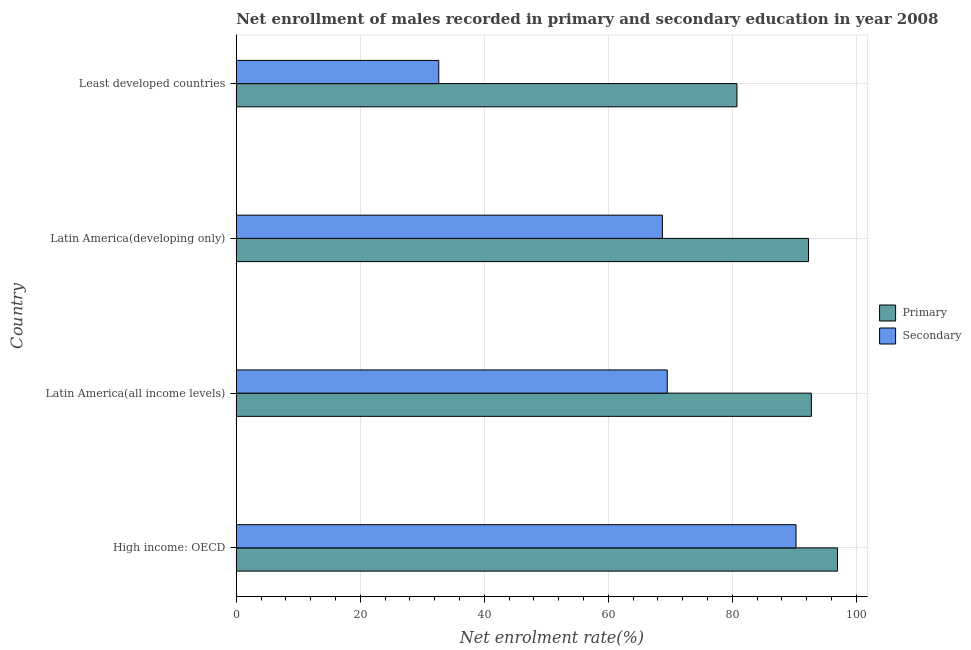Are the number of bars per tick equal to the number of legend labels?
Your answer should be compact. Yes. Are the number of bars on each tick of the Y-axis equal?
Offer a very short reply. Yes. How many bars are there on the 1st tick from the top?
Offer a terse response. 2. What is the label of the 1st group of bars from the top?
Provide a succinct answer. Least developed countries. In how many cases, is the number of bars for a given country not equal to the number of legend labels?
Make the answer very short. 0. What is the enrollment rate in primary education in Latin America(developing only)?
Offer a terse response. 92.29. Across all countries, what is the maximum enrollment rate in secondary education?
Provide a short and direct response. 90.28. Across all countries, what is the minimum enrollment rate in secondary education?
Offer a very short reply. 32.66. In which country was the enrollment rate in secondary education maximum?
Ensure brevity in your answer.  High income: OECD. In which country was the enrollment rate in secondary education minimum?
Provide a short and direct response. Least developed countries. What is the total enrollment rate in primary education in the graph?
Your answer should be compact. 362.76. What is the difference between the enrollment rate in primary education in Latin America(developing only) and that in Least developed countries?
Make the answer very short. 11.53. What is the difference between the enrollment rate in secondary education in High income: OECD and the enrollment rate in primary education in Latin America(developing only)?
Provide a succinct answer. -2.01. What is the average enrollment rate in secondary education per country?
Offer a terse response. 65.29. What is the difference between the enrollment rate in secondary education and enrollment rate in primary education in Latin America(all income levels)?
Provide a succinct answer. -23.24. In how many countries, is the enrollment rate in secondary education greater than 32 %?
Provide a short and direct response. 4. What is the ratio of the enrollment rate in primary education in Latin America(all income levels) to that in Least developed countries?
Give a very brief answer. 1.15. What is the difference between the highest and the second highest enrollment rate in secondary education?
Offer a terse response. 20.77. What is the difference between the highest and the lowest enrollment rate in secondary education?
Your answer should be very brief. 57.61. Is the sum of the enrollment rate in secondary education in High income: OECD and Latin America(all income levels) greater than the maximum enrollment rate in primary education across all countries?
Provide a succinct answer. Yes. What does the 2nd bar from the top in Least developed countries represents?
Give a very brief answer. Primary. What does the 2nd bar from the bottom in Latin America(developing only) represents?
Ensure brevity in your answer.  Secondary. How many bars are there?
Keep it short and to the point. 8. Does the graph contain any zero values?
Provide a short and direct response. No. Does the graph contain grids?
Offer a terse response. Yes. Where does the legend appear in the graph?
Your answer should be very brief. Center right. How many legend labels are there?
Ensure brevity in your answer.  2. How are the legend labels stacked?
Offer a terse response. Vertical. What is the title of the graph?
Your response must be concise. Net enrollment of males recorded in primary and secondary education in year 2008. Does "Under-5(female)" appear as one of the legend labels in the graph?
Make the answer very short. No. What is the label or title of the X-axis?
Give a very brief answer. Net enrolment rate(%). What is the Net enrolment rate(%) in Primary in High income: OECD?
Offer a terse response. 96.97. What is the Net enrolment rate(%) of Secondary in High income: OECD?
Keep it short and to the point. 90.28. What is the Net enrolment rate(%) of Primary in Latin America(all income levels)?
Your response must be concise. 92.75. What is the Net enrolment rate(%) in Secondary in Latin America(all income levels)?
Offer a very short reply. 69.51. What is the Net enrolment rate(%) of Primary in Latin America(developing only)?
Offer a terse response. 92.29. What is the Net enrolment rate(%) of Secondary in Latin America(developing only)?
Make the answer very short. 68.72. What is the Net enrolment rate(%) in Primary in Least developed countries?
Offer a very short reply. 80.75. What is the Net enrolment rate(%) of Secondary in Least developed countries?
Your response must be concise. 32.66. Across all countries, what is the maximum Net enrolment rate(%) in Primary?
Your answer should be very brief. 96.97. Across all countries, what is the maximum Net enrolment rate(%) of Secondary?
Make the answer very short. 90.28. Across all countries, what is the minimum Net enrolment rate(%) in Primary?
Give a very brief answer. 80.75. Across all countries, what is the minimum Net enrolment rate(%) in Secondary?
Offer a very short reply. 32.66. What is the total Net enrolment rate(%) in Primary in the graph?
Provide a short and direct response. 362.76. What is the total Net enrolment rate(%) in Secondary in the graph?
Ensure brevity in your answer.  261.17. What is the difference between the Net enrolment rate(%) of Primary in High income: OECD and that in Latin America(all income levels)?
Your response must be concise. 4.22. What is the difference between the Net enrolment rate(%) in Secondary in High income: OECD and that in Latin America(all income levels)?
Offer a terse response. 20.77. What is the difference between the Net enrolment rate(%) of Primary in High income: OECD and that in Latin America(developing only)?
Your response must be concise. 4.68. What is the difference between the Net enrolment rate(%) in Secondary in High income: OECD and that in Latin America(developing only)?
Your response must be concise. 21.55. What is the difference between the Net enrolment rate(%) in Primary in High income: OECD and that in Least developed countries?
Keep it short and to the point. 16.22. What is the difference between the Net enrolment rate(%) in Secondary in High income: OECD and that in Least developed countries?
Provide a short and direct response. 57.61. What is the difference between the Net enrolment rate(%) in Primary in Latin America(all income levels) and that in Latin America(developing only)?
Offer a terse response. 0.46. What is the difference between the Net enrolment rate(%) in Secondary in Latin America(all income levels) and that in Latin America(developing only)?
Your answer should be compact. 0.78. What is the difference between the Net enrolment rate(%) in Primary in Latin America(all income levels) and that in Least developed countries?
Provide a short and direct response. 12. What is the difference between the Net enrolment rate(%) in Secondary in Latin America(all income levels) and that in Least developed countries?
Ensure brevity in your answer.  36.85. What is the difference between the Net enrolment rate(%) in Primary in Latin America(developing only) and that in Least developed countries?
Keep it short and to the point. 11.53. What is the difference between the Net enrolment rate(%) in Secondary in Latin America(developing only) and that in Least developed countries?
Your answer should be very brief. 36.06. What is the difference between the Net enrolment rate(%) of Primary in High income: OECD and the Net enrolment rate(%) of Secondary in Latin America(all income levels)?
Make the answer very short. 27.46. What is the difference between the Net enrolment rate(%) in Primary in High income: OECD and the Net enrolment rate(%) in Secondary in Latin America(developing only)?
Give a very brief answer. 28.24. What is the difference between the Net enrolment rate(%) in Primary in High income: OECD and the Net enrolment rate(%) in Secondary in Least developed countries?
Offer a very short reply. 64.31. What is the difference between the Net enrolment rate(%) in Primary in Latin America(all income levels) and the Net enrolment rate(%) in Secondary in Latin America(developing only)?
Provide a short and direct response. 24.03. What is the difference between the Net enrolment rate(%) in Primary in Latin America(all income levels) and the Net enrolment rate(%) in Secondary in Least developed countries?
Give a very brief answer. 60.09. What is the difference between the Net enrolment rate(%) in Primary in Latin America(developing only) and the Net enrolment rate(%) in Secondary in Least developed countries?
Provide a succinct answer. 59.62. What is the average Net enrolment rate(%) of Primary per country?
Give a very brief answer. 90.69. What is the average Net enrolment rate(%) in Secondary per country?
Provide a short and direct response. 65.29. What is the difference between the Net enrolment rate(%) of Primary and Net enrolment rate(%) of Secondary in High income: OECD?
Give a very brief answer. 6.69. What is the difference between the Net enrolment rate(%) of Primary and Net enrolment rate(%) of Secondary in Latin America(all income levels)?
Keep it short and to the point. 23.24. What is the difference between the Net enrolment rate(%) in Primary and Net enrolment rate(%) in Secondary in Latin America(developing only)?
Keep it short and to the point. 23.56. What is the difference between the Net enrolment rate(%) of Primary and Net enrolment rate(%) of Secondary in Least developed countries?
Your response must be concise. 48.09. What is the ratio of the Net enrolment rate(%) of Primary in High income: OECD to that in Latin America(all income levels)?
Ensure brevity in your answer.  1.05. What is the ratio of the Net enrolment rate(%) in Secondary in High income: OECD to that in Latin America(all income levels)?
Offer a very short reply. 1.3. What is the ratio of the Net enrolment rate(%) of Primary in High income: OECD to that in Latin America(developing only)?
Your answer should be very brief. 1.05. What is the ratio of the Net enrolment rate(%) of Secondary in High income: OECD to that in Latin America(developing only)?
Offer a terse response. 1.31. What is the ratio of the Net enrolment rate(%) of Primary in High income: OECD to that in Least developed countries?
Your answer should be very brief. 1.2. What is the ratio of the Net enrolment rate(%) of Secondary in High income: OECD to that in Least developed countries?
Provide a short and direct response. 2.76. What is the ratio of the Net enrolment rate(%) in Primary in Latin America(all income levels) to that in Latin America(developing only)?
Offer a terse response. 1. What is the ratio of the Net enrolment rate(%) of Secondary in Latin America(all income levels) to that in Latin America(developing only)?
Keep it short and to the point. 1.01. What is the ratio of the Net enrolment rate(%) of Primary in Latin America(all income levels) to that in Least developed countries?
Your answer should be compact. 1.15. What is the ratio of the Net enrolment rate(%) in Secondary in Latin America(all income levels) to that in Least developed countries?
Your answer should be very brief. 2.13. What is the ratio of the Net enrolment rate(%) in Primary in Latin America(developing only) to that in Least developed countries?
Your response must be concise. 1.14. What is the ratio of the Net enrolment rate(%) of Secondary in Latin America(developing only) to that in Least developed countries?
Provide a succinct answer. 2.1. What is the difference between the highest and the second highest Net enrolment rate(%) of Primary?
Ensure brevity in your answer.  4.22. What is the difference between the highest and the second highest Net enrolment rate(%) of Secondary?
Give a very brief answer. 20.77. What is the difference between the highest and the lowest Net enrolment rate(%) in Primary?
Offer a very short reply. 16.22. What is the difference between the highest and the lowest Net enrolment rate(%) of Secondary?
Provide a short and direct response. 57.61. 